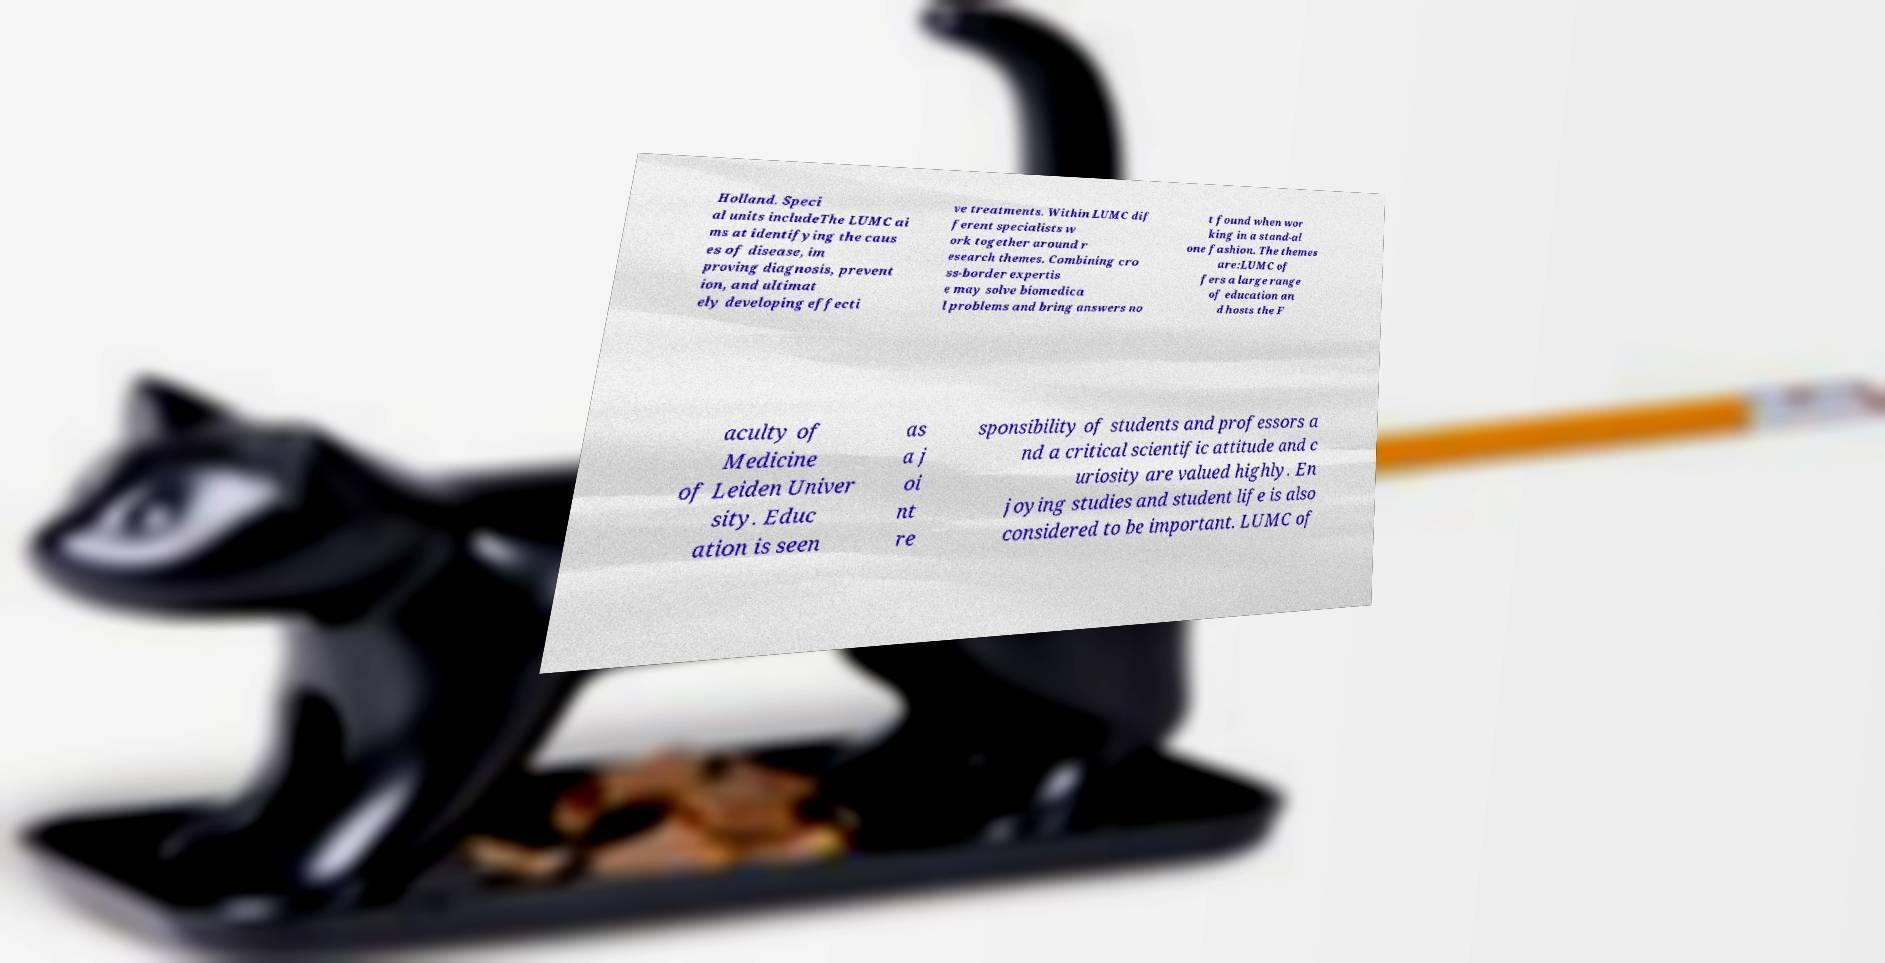What messages or text are displayed in this image? I need them in a readable, typed format. Holland. Speci al units includeThe LUMC ai ms at identifying the caus es of disease, im proving diagnosis, prevent ion, and ultimat ely developing effecti ve treatments. Within LUMC dif ferent specialists w ork together around r esearch themes. Combining cro ss-border expertis e may solve biomedica l problems and bring answers no t found when wor king in a stand-al one fashion. The themes are:LUMC of fers a large range of education an d hosts the F aculty of Medicine of Leiden Univer sity. Educ ation is seen as a j oi nt re sponsibility of students and professors a nd a critical scientific attitude and c uriosity are valued highly. En joying studies and student life is also considered to be important. LUMC of 